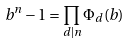Convert formula to latex. <formula><loc_0><loc_0><loc_500><loc_500>b ^ { n } - 1 = \prod _ { d | n } \Phi _ { d } ( b )</formula> 